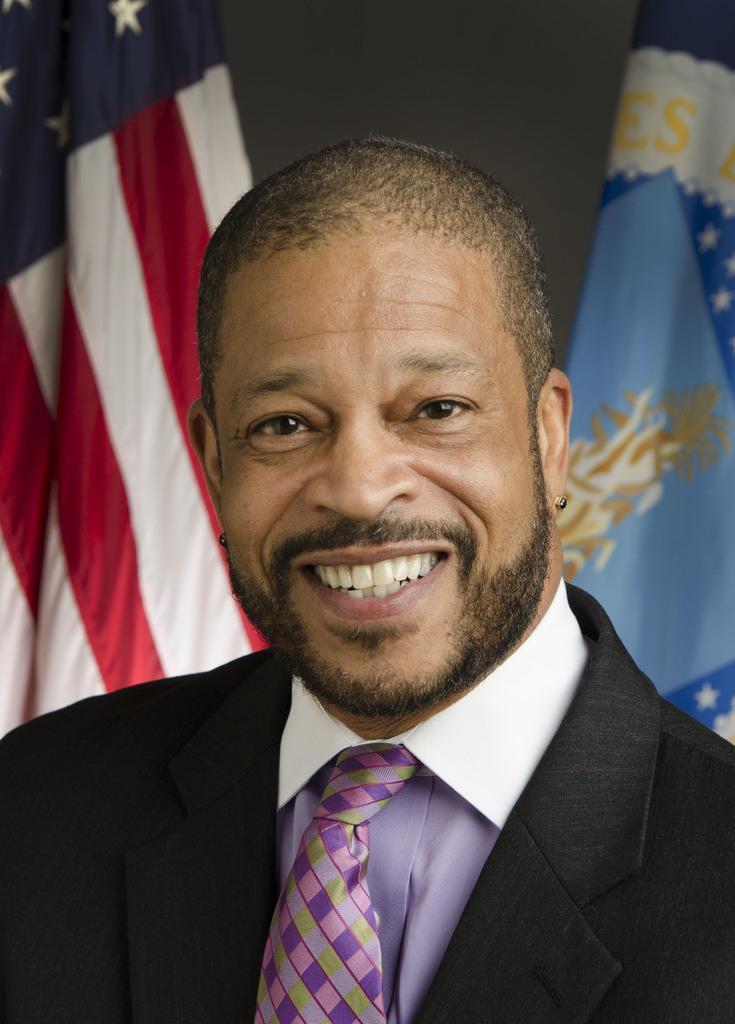Please provide a concise description of this image. In this image I can see a person wearing white shirt, tie and black blazer and in the background I can see two flags. 